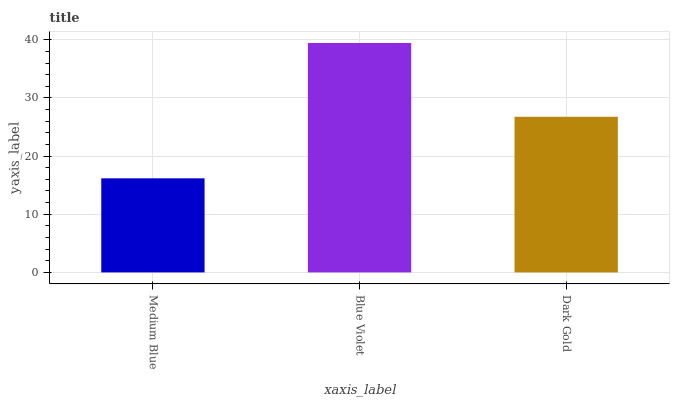Is Medium Blue the minimum?
Answer yes or no. Yes. Is Blue Violet the maximum?
Answer yes or no. Yes. Is Dark Gold the minimum?
Answer yes or no. No. Is Dark Gold the maximum?
Answer yes or no. No. Is Blue Violet greater than Dark Gold?
Answer yes or no. Yes. Is Dark Gold less than Blue Violet?
Answer yes or no. Yes. Is Dark Gold greater than Blue Violet?
Answer yes or no. No. Is Blue Violet less than Dark Gold?
Answer yes or no. No. Is Dark Gold the high median?
Answer yes or no. Yes. Is Dark Gold the low median?
Answer yes or no. Yes. Is Blue Violet the high median?
Answer yes or no. No. Is Blue Violet the low median?
Answer yes or no. No. 